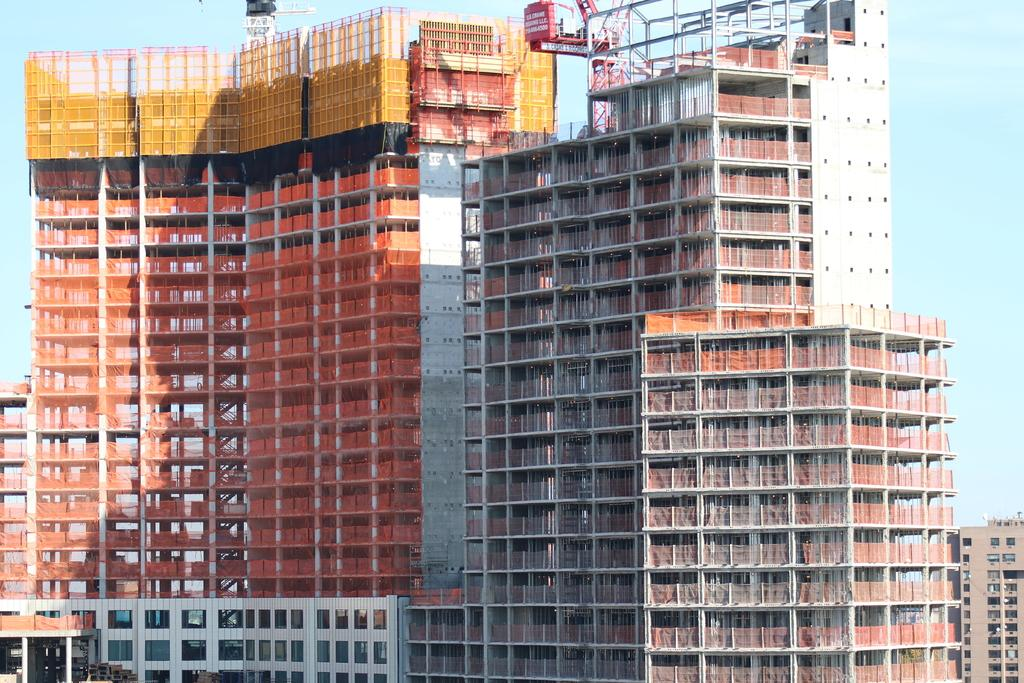What type of structures can be seen in the image? There are buildings in the image. What part of the natural environment is visible in the image? The sky is visible in the background of the image. What type of stew is being served at the party in the image? There is no party or stew present in the image; it only features buildings and the sky. 